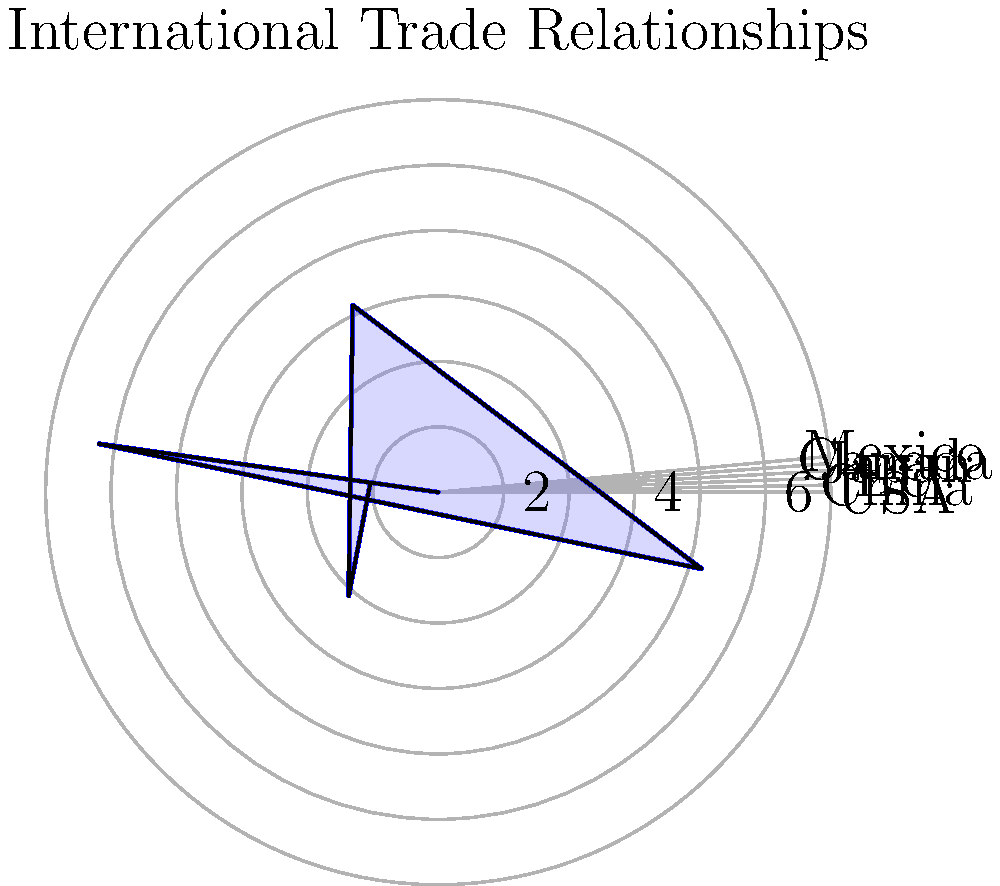As an attaché analyzing international trade relationships, you are presented with a polar plot showing trade volumes between your country and six major trading partners. The radial axis represents trade volume in billions of dollars, while each angular position represents a different country. If your country's total trade volume across these partners is 23 billion dollars, what percentage of this total is represented by trade with Canada? To solve this problem, we need to follow these steps:

1. Identify Canada's position on the polar plot:
   Canada is located at the 4pi/3 position (240 degrees).

2. Determine Canada's trade volume:
   The radial value for Canada extends to the 6 billion mark.

3. Calculate the total trade volume:
   We're given that the total trade volume is 23 billion dollars.

4. Calculate the percentage of trade with Canada:
   Let $x$ be the percentage we're looking for.
   
   $x = \frac{\text{Canada's trade volume}}{\text{Total trade volume}} \times 100\%$
   
   $x = \frac{6}{23} \times 100\%$
   
   $x = 0.2608695652 \times 100\%$
   
   $x \approx 26.09\%$

5. Round to the nearest whole percentage:
   26.09% rounds to 26%

Therefore, trade with Canada represents approximately 26% of the total trade volume.
Answer: 26% 